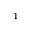<formula> <loc_0><loc_0><loc_500><loc_500>^ { 1 }</formula> 